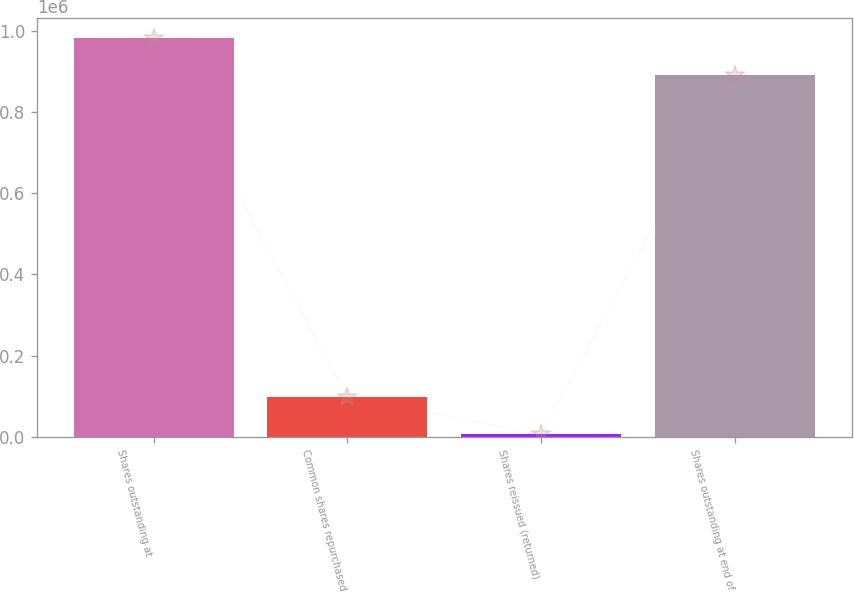Convert chart. <chart><loc_0><loc_0><loc_500><loc_500><bar_chart><fcel>Shares outstanding at<fcel>Common shares repurchased<fcel>Shares reissued (returned)<fcel>Shares outstanding at end of<nl><fcel>982646<fcel>98475.5<fcel>6554<fcel>890724<nl></chart> 